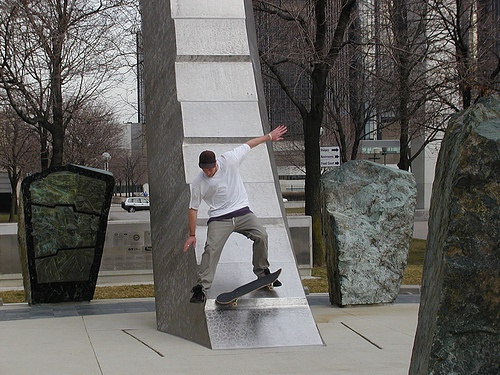Describe the objects in this image and their specific colors. I can see people in gray, darkgray, lightgray, and black tones, skateboard in gray, black, and darkgray tones, and car in gray, black, darkgray, and lightgray tones in this image. 